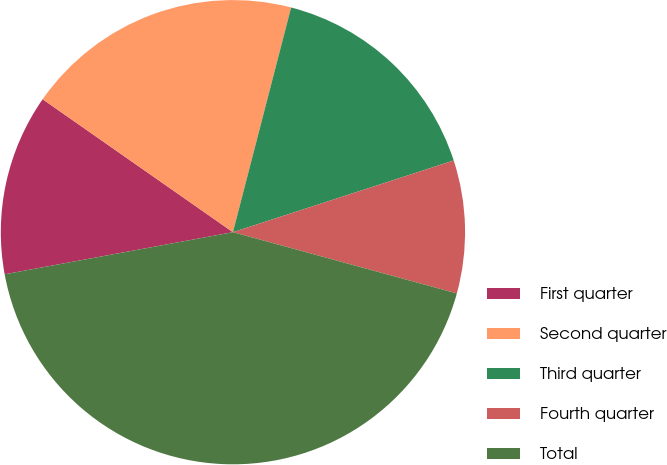Convert chart to OTSL. <chart><loc_0><loc_0><loc_500><loc_500><pie_chart><fcel>First quarter<fcel>Second quarter<fcel>Third quarter<fcel>Fourth quarter<fcel>Total<nl><fcel>12.61%<fcel>19.33%<fcel>15.97%<fcel>9.25%<fcel>42.85%<nl></chart> 